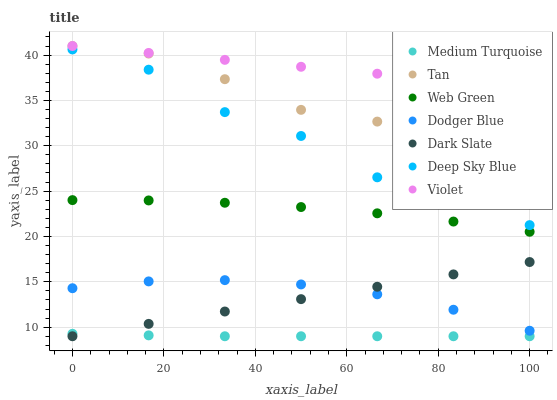Does Medium Turquoise have the minimum area under the curve?
Answer yes or no. Yes. Does Violet have the maximum area under the curve?
Answer yes or no. Yes. Does Web Green have the minimum area under the curve?
Answer yes or no. No. Does Web Green have the maximum area under the curve?
Answer yes or no. No. Is Dark Slate the smoothest?
Answer yes or no. Yes. Is Deep Sky Blue the roughest?
Answer yes or no. Yes. Is Web Green the smoothest?
Answer yes or no. No. Is Web Green the roughest?
Answer yes or no. No. Does Dark Slate have the lowest value?
Answer yes or no. Yes. Does Web Green have the lowest value?
Answer yes or no. No. Does Tan have the highest value?
Answer yes or no. Yes. Does Web Green have the highest value?
Answer yes or no. No. Is Web Green less than Tan?
Answer yes or no. Yes. Is Dodger Blue greater than Medium Turquoise?
Answer yes or no. Yes. Does Dark Slate intersect Dodger Blue?
Answer yes or no. Yes. Is Dark Slate less than Dodger Blue?
Answer yes or no. No. Is Dark Slate greater than Dodger Blue?
Answer yes or no. No. Does Web Green intersect Tan?
Answer yes or no. No. 